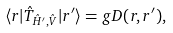Convert formula to latex. <formula><loc_0><loc_0><loc_500><loc_500>\langle { r } | \hat { T } _ { \hat { H } ^ { \prime } , \hat { V } } | { r ^ { \prime } } \rangle = g D ( { r } , { r } ^ { \prime } ) ,</formula> 